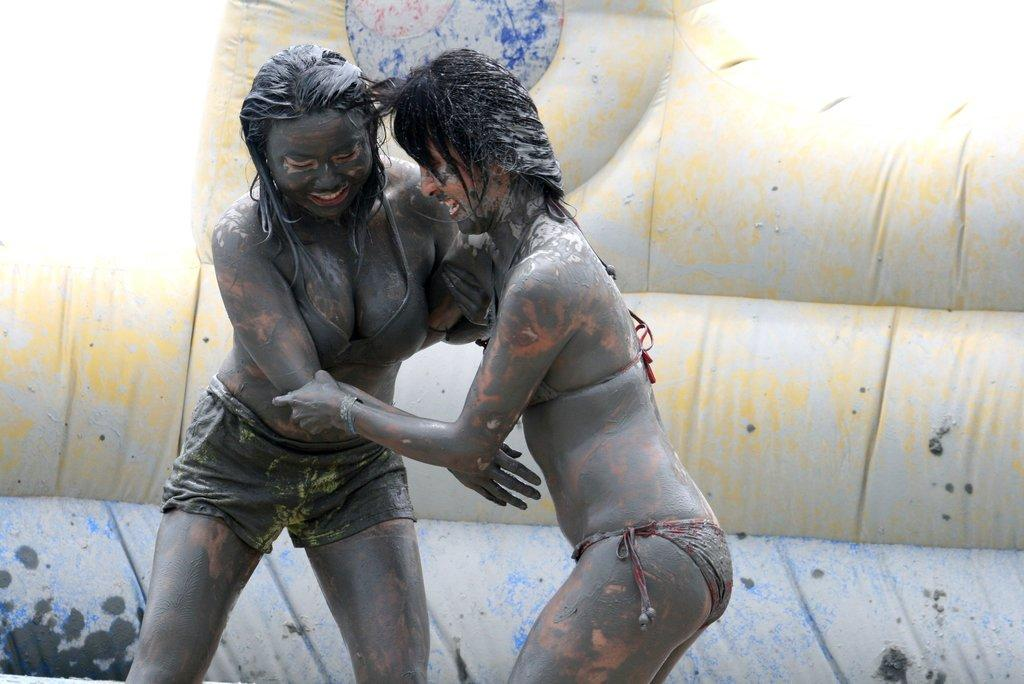How many girls are in the image? There are two girls in the image. What are the girls doing in the image? The girls are holding hands in the image. What can be observed on the girls' bodies? There is mud on the girls' bodies. What is present in the background of the image? There is a cloth in the background of the image. What can be seen on the cloth? The cloth has mud stains on it. Where is the rabbit located in the image? There is no rabbit present in the image. How many people are in the crowd in the image? There is no crowd present in the image; it only features two girls. 